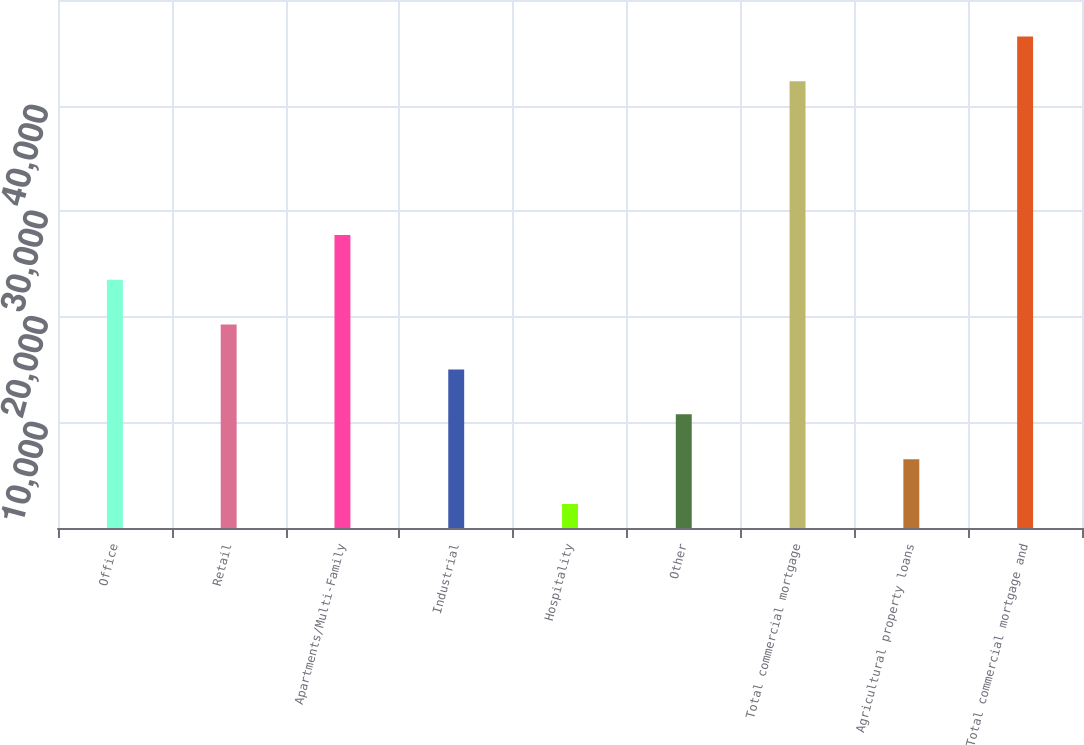Convert chart to OTSL. <chart><loc_0><loc_0><loc_500><loc_500><bar_chart><fcel>Office<fcel>Retail<fcel>Apartments/Multi-Family<fcel>Industrial<fcel>Hospitality<fcel>Other<fcel>Total commercial mortgage<fcel>Agricultural property loans<fcel>Total commercial mortgage and<nl><fcel>23509<fcel>19261.2<fcel>27756.8<fcel>15013.4<fcel>2270<fcel>10765.6<fcel>42303<fcel>6517.8<fcel>46550.8<nl></chart> 